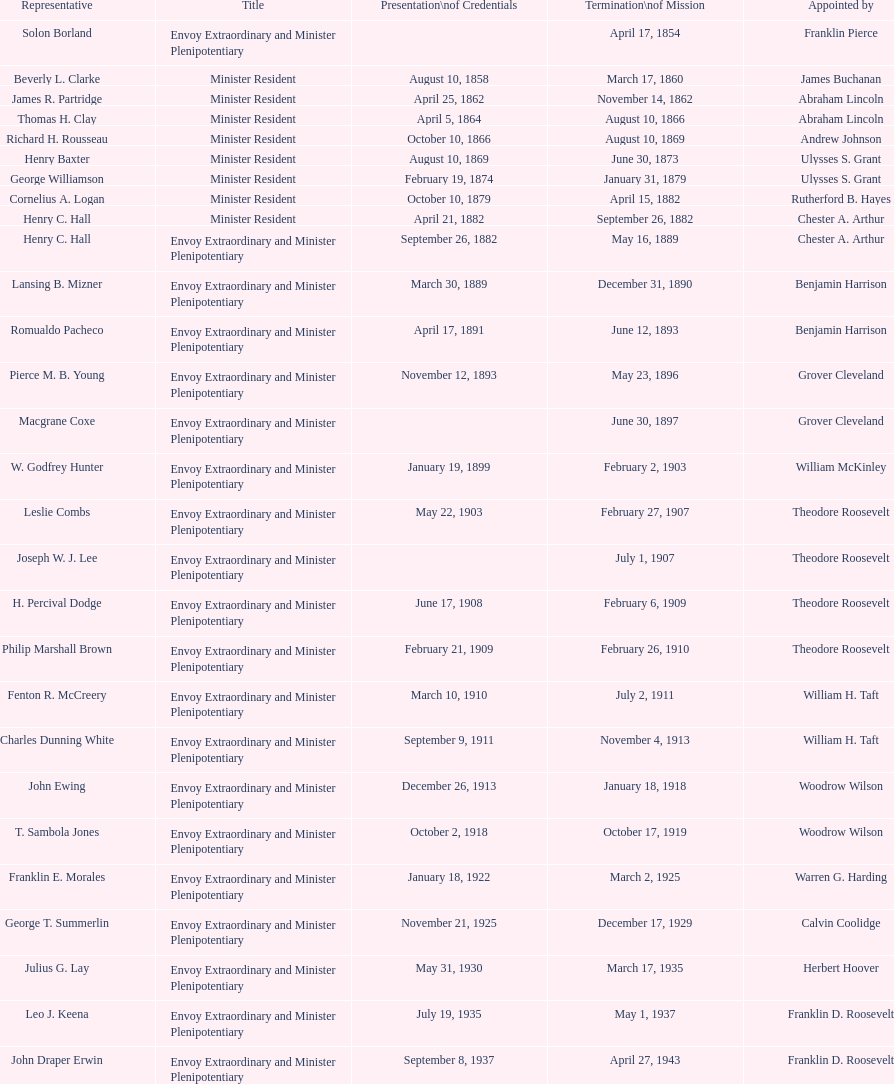Parse the full table. {'header': ['Representative', 'Title', 'Presentation\\nof Credentials', 'Termination\\nof Mission', 'Appointed by'], 'rows': [['Solon Borland', 'Envoy Extraordinary and Minister Plenipotentiary', '', 'April 17, 1854', 'Franklin Pierce'], ['Beverly L. Clarke', 'Minister Resident', 'August 10, 1858', 'March 17, 1860', 'James Buchanan'], ['James R. Partridge', 'Minister Resident', 'April 25, 1862', 'November 14, 1862', 'Abraham Lincoln'], ['Thomas H. Clay', 'Minister Resident', 'April 5, 1864', 'August 10, 1866', 'Abraham Lincoln'], ['Richard H. Rousseau', 'Minister Resident', 'October 10, 1866', 'August 10, 1869', 'Andrew Johnson'], ['Henry Baxter', 'Minister Resident', 'August 10, 1869', 'June 30, 1873', 'Ulysses S. Grant'], ['George Williamson', 'Minister Resident', 'February 19, 1874', 'January 31, 1879', 'Ulysses S. Grant'], ['Cornelius A. Logan', 'Minister Resident', 'October 10, 1879', 'April 15, 1882', 'Rutherford B. Hayes'], ['Henry C. Hall', 'Minister Resident', 'April 21, 1882', 'September 26, 1882', 'Chester A. Arthur'], ['Henry C. Hall', 'Envoy Extraordinary and Minister Plenipotentiary', 'September 26, 1882', 'May 16, 1889', 'Chester A. Arthur'], ['Lansing B. Mizner', 'Envoy Extraordinary and Minister Plenipotentiary', 'March 30, 1889', 'December 31, 1890', 'Benjamin Harrison'], ['Romualdo Pacheco', 'Envoy Extraordinary and Minister Plenipotentiary', 'April 17, 1891', 'June 12, 1893', 'Benjamin Harrison'], ['Pierce M. B. Young', 'Envoy Extraordinary and Minister Plenipotentiary', 'November 12, 1893', 'May 23, 1896', 'Grover Cleveland'], ['Macgrane Coxe', 'Envoy Extraordinary and Minister Plenipotentiary', '', 'June 30, 1897', 'Grover Cleveland'], ['W. Godfrey Hunter', 'Envoy Extraordinary and Minister Plenipotentiary', 'January 19, 1899', 'February 2, 1903', 'William McKinley'], ['Leslie Combs', 'Envoy Extraordinary and Minister Plenipotentiary', 'May 22, 1903', 'February 27, 1907', 'Theodore Roosevelt'], ['Joseph W. J. Lee', 'Envoy Extraordinary and Minister Plenipotentiary', '', 'July 1, 1907', 'Theodore Roosevelt'], ['H. Percival Dodge', 'Envoy Extraordinary and Minister Plenipotentiary', 'June 17, 1908', 'February 6, 1909', 'Theodore Roosevelt'], ['Philip Marshall Brown', 'Envoy Extraordinary and Minister Plenipotentiary', 'February 21, 1909', 'February 26, 1910', 'Theodore Roosevelt'], ['Fenton R. McCreery', 'Envoy Extraordinary and Minister Plenipotentiary', 'March 10, 1910', 'July 2, 1911', 'William H. Taft'], ['Charles Dunning White', 'Envoy Extraordinary and Minister Plenipotentiary', 'September 9, 1911', 'November 4, 1913', 'William H. Taft'], ['John Ewing', 'Envoy Extraordinary and Minister Plenipotentiary', 'December 26, 1913', 'January 18, 1918', 'Woodrow Wilson'], ['T. Sambola Jones', 'Envoy Extraordinary and Minister Plenipotentiary', 'October 2, 1918', 'October 17, 1919', 'Woodrow Wilson'], ['Franklin E. Morales', 'Envoy Extraordinary and Minister Plenipotentiary', 'January 18, 1922', 'March 2, 1925', 'Warren G. Harding'], ['George T. Summerlin', 'Envoy Extraordinary and Minister Plenipotentiary', 'November 21, 1925', 'December 17, 1929', 'Calvin Coolidge'], ['Julius G. Lay', 'Envoy Extraordinary and Minister Plenipotentiary', 'May 31, 1930', 'March 17, 1935', 'Herbert Hoover'], ['Leo J. Keena', 'Envoy Extraordinary and Minister Plenipotentiary', 'July 19, 1935', 'May 1, 1937', 'Franklin D. Roosevelt'], ['John Draper Erwin', 'Envoy Extraordinary and Minister Plenipotentiary', 'September 8, 1937', 'April 27, 1943', 'Franklin D. Roosevelt'], ['John Draper Erwin', 'Ambassador Extraordinary and Plenipotentiary', 'April 27, 1943', 'April 16, 1947', 'Franklin D. Roosevelt'], ['Paul C. Daniels', 'Ambassador Extraordinary and Plenipotentiary', 'June 23, 1947', 'October 30, 1947', 'Harry S. Truman'], ['Herbert S. Bursley', 'Ambassador Extraordinary and Plenipotentiary', 'May 15, 1948', 'December 12, 1950', 'Harry S. Truman'], ['John Draper Erwin', 'Ambassador Extraordinary and Plenipotentiary', 'March 14, 1951', 'February 28, 1954', 'Harry S. Truman'], ['Whiting Willauer', 'Ambassador Extraordinary and Plenipotentiary', 'March 5, 1954', 'March 24, 1958', 'Dwight D. Eisenhower'], ['Robert Newbegin', 'Ambassador Extraordinary and Plenipotentiary', 'April 30, 1958', 'August 3, 1960', 'Dwight D. Eisenhower'], ['Charles R. Burrows', 'Ambassador Extraordinary and Plenipotentiary', 'November 3, 1960', 'June 28, 1965', 'Dwight D. Eisenhower'], ['Joseph J. Jova', 'Ambassador Extraordinary and Plenipotentiary', 'July 12, 1965', 'June 21, 1969', 'Lyndon B. Johnson'], ['Hewson A. Ryan', 'Ambassador Extraordinary and Plenipotentiary', 'November 5, 1969', 'May 30, 1973', 'Richard Nixon'], ['Phillip V. Sanchez', 'Ambassador Extraordinary and Plenipotentiary', 'June 15, 1973', 'July 17, 1976', 'Richard Nixon'], ['Ralph E. Becker', 'Ambassador Extraordinary and Plenipotentiary', 'October 27, 1976', 'August 1, 1977', 'Gerald Ford'], ['Mari-Luci Jaramillo', 'Ambassador Extraordinary and Plenipotentiary', 'October 27, 1977', 'September 19, 1980', 'Jimmy Carter'], ['Jack R. Binns', 'Ambassador Extraordinary and Plenipotentiary', 'October 10, 1980', 'October 31, 1981', 'Jimmy Carter'], ['John D. Negroponte', 'Ambassador Extraordinary and Plenipotentiary', 'November 11, 1981', 'May 30, 1985', 'Ronald Reagan'], ['John Arthur Ferch', 'Ambassador Extraordinary and Plenipotentiary', 'August 22, 1985', 'July 9, 1986', 'Ronald Reagan'], ['Everett Ellis Briggs', 'Ambassador Extraordinary and Plenipotentiary', 'November 4, 1986', 'June 15, 1989', 'Ronald Reagan'], ['Cresencio S. Arcos, Jr.', 'Ambassador Extraordinary and Plenipotentiary', 'January 29, 1990', 'July 1, 1993', 'George H. W. Bush'], ['William Thornton Pryce', 'Ambassador Extraordinary and Plenipotentiary', 'July 21, 1993', 'August 15, 1996', 'Bill Clinton'], ['James F. Creagan', 'Ambassador Extraordinary and Plenipotentiary', 'August 29, 1996', 'July 20, 1999', 'Bill Clinton'], ['Frank Almaguer', 'Ambassador Extraordinary and Plenipotentiary', 'August 25, 1999', 'September 5, 2002', 'Bill Clinton'], ['Larry Leon Palmer', 'Ambassador Extraordinary and Plenipotentiary', 'October 8, 2002', 'May 7, 2005', 'George W. Bush'], ['Charles A. Ford', 'Ambassador Extraordinary and Plenipotentiary', 'November 8, 2005', 'ca. April 2008', 'George W. Bush'], ['Hugo Llorens', 'Ambassador Extraordinary and Plenipotentiary', 'September 19, 2008', 'ca. July 2011', 'George W. Bush'], ['Lisa Kubiske', 'Ambassador Extraordinary and Plenipotentiary', 'July 26, 2011', 'Incumbent', 'Barack Obama']]} Who is the only ambassadors to honduras appointed by barack obama? Lisa Kubiske. 